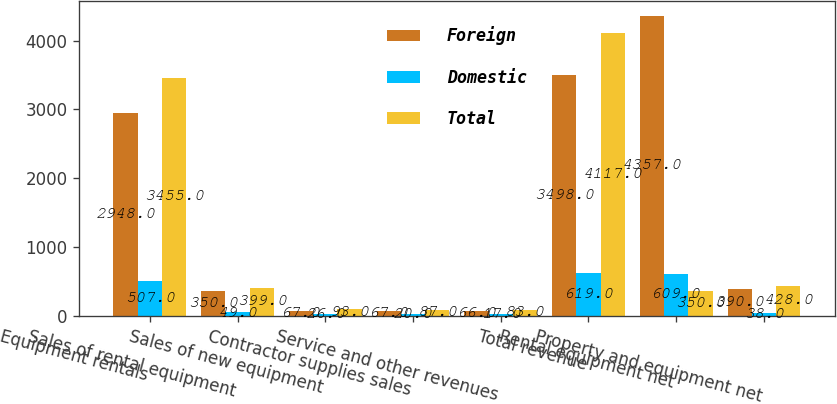Convert chart. <chart><loc_0><loc_0><loc_500><loc_500><stacked_bar_chart><ecel><fcel>Equipment rentals<fcel>Sales of rental equipment<fcel>Sales of new equipment<fcel>Contractor supplies sales<fcel>Service and other revenues<fcel>Total revenue<fcel>Rental equipment net<fcel>Property and equipment net<nl><fcel>Foreign<fcel>2948<fcel>350<fcel>67<fcel>67<fcel>66<fcel>3498<fcel>4357<fcel>390<nl><fcel>Domestic<fcel>507<fcel>49<fcel>26<fcel>20<fcel>17<fcel>619<fcel>609<fcel>38<nl><fcel>Total<fcel>3455<fcel>399<fcel>93<fcel>87<fcel>83<fcel>4117<fcel>350<fcel>428<nl></chart> 